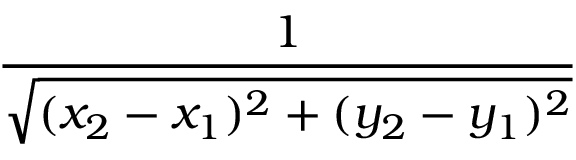Convert formula to latex. <formula><loc_0><loc_0><loc_500><loc_500>\frac { 1 } { \sqrt { ( x _ { 2 } - x _ { 1 } ) ^ { 2 } + ( y _ { 2 } - y _ { 1 } ) ^ { 2 } } }</formula> 